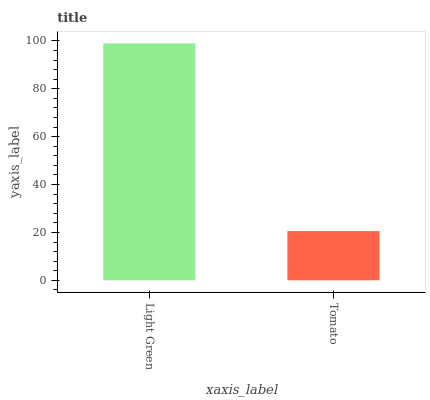Is Tomato the maximum?
Answer yes or no. No. Is Light Green greater than Tomato?
Answer yes or no. Yes. Is Tomato less than Light Green?
Answer yes or no. Yes. Is Tomato greater than Light Green?
Answer yes or no. No. Is Light Green less than Tomato?
Answer yes or no. No. Is Light Green the high median?
Answer yes or no. Yes. Is Tomato the low median?
Answer yes or no. Yes. Is Tomato the high median?
Answer yes or no. No. Is Light Green the low median?
Answer yes or no. No. 